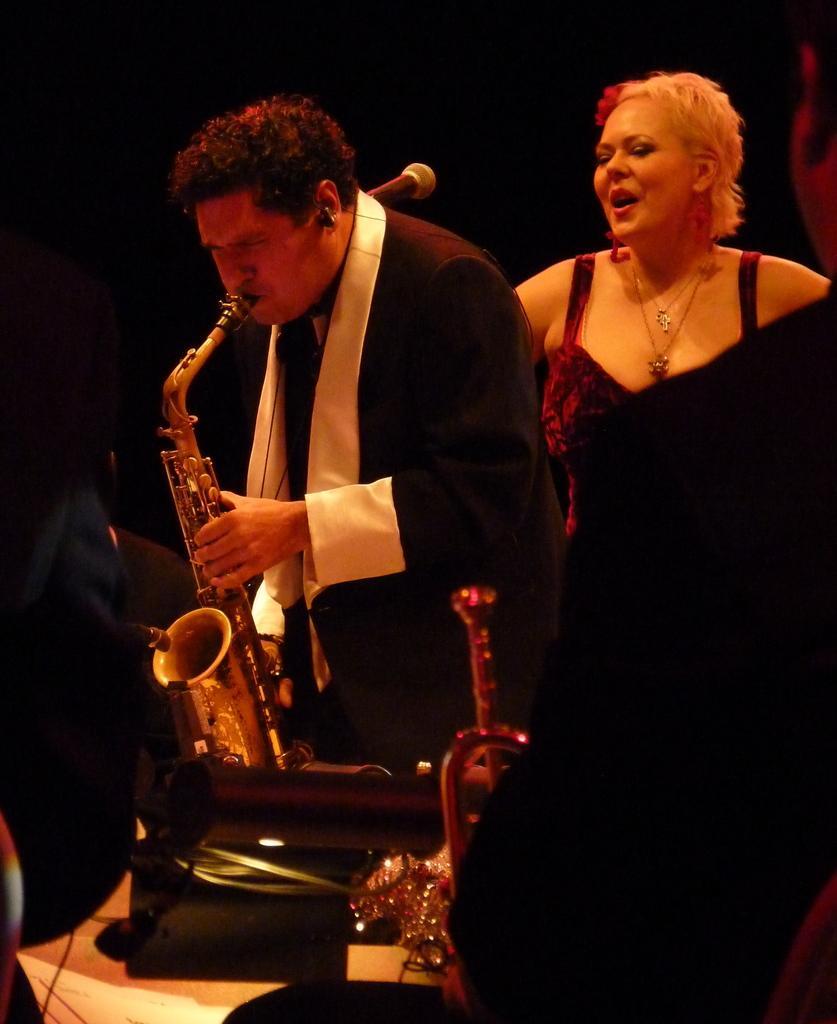Could you give a brief overview of what you see in this image? In this picture we can see a man wearing black suit and playing saxophone. Behind we can see a woman standing and smiling. Behind there is a dark background. 